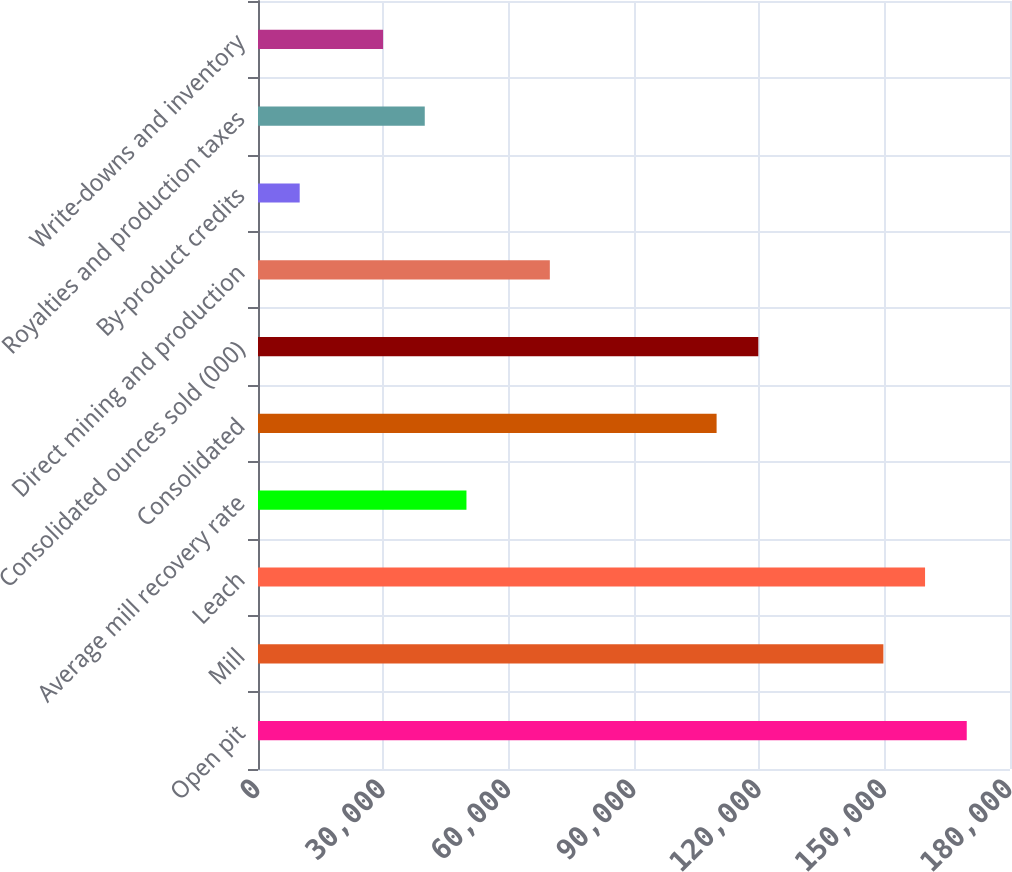<chart> <loc_0><loc_0><loc_500><loc_500><bar_chart><fcel>Open pit<fcel>Mill<fcel>Leach<fcel>Average mill recovery rate<fcel>Consolidated<fcel>Consolidated ounces sold (000)<fcel>Direct mining and production<fcel>By-product credits<fcel>Royalties and production taxes<fcel>Write-downs and inventory<nl><fcel>169648<fcel>149689<fcel>159669<fcel>49896.5<fcel>109772<fcel>119752<fcel>69855.1<fcel>9979.35<fcel>39917.2<fcel>29937.9<nl></chart> 